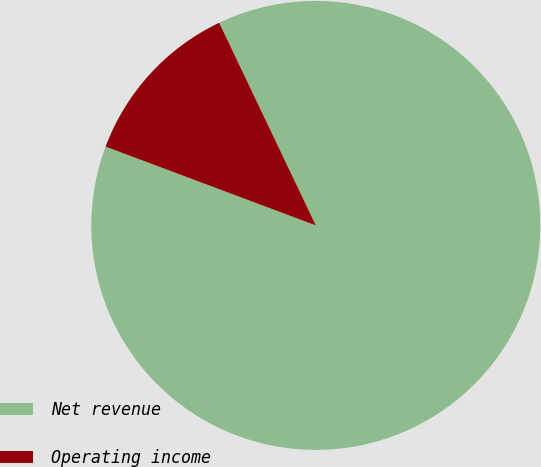<chart> <loc_0><loc_0><loc_500><loc_500><pie_chart><fcel>Net revenue<fcel>Operating income<nl><fcel>87.79%<fcel>12.21%<nl></chart> 